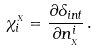Convert formula to latex. <formula><loc_0><loc_0><loc_500><loc_500>\chi ^ { _ { X } } _ { i } = \frac { \partial \Lambda _ { i n t } } { \partial n _ { _ { X } } ^ { i } } \, .</formula> 